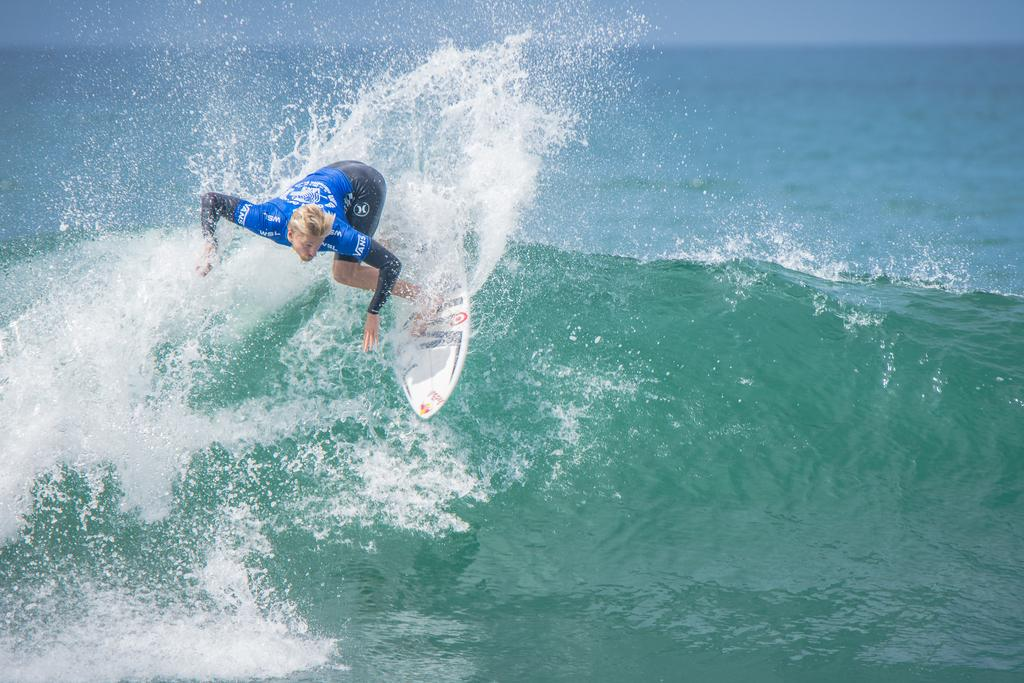What is the main subject of the image? There is a person in the image. What is the person doing in the image? The person is on a surfboard. What is the person wearing in the image? The person is wearing a blue and black color dress. What can be seen in the background of the image? The background of the image includes water. Can you see any icicles hanging from the person's dress in the image? There are no icicles present in the image; the person is wearing a dress in a water setting, not a cold environment. Is there a rabbit visible in the image? There is no rabbit present in the image; the main subject is a person on a surfboard. 